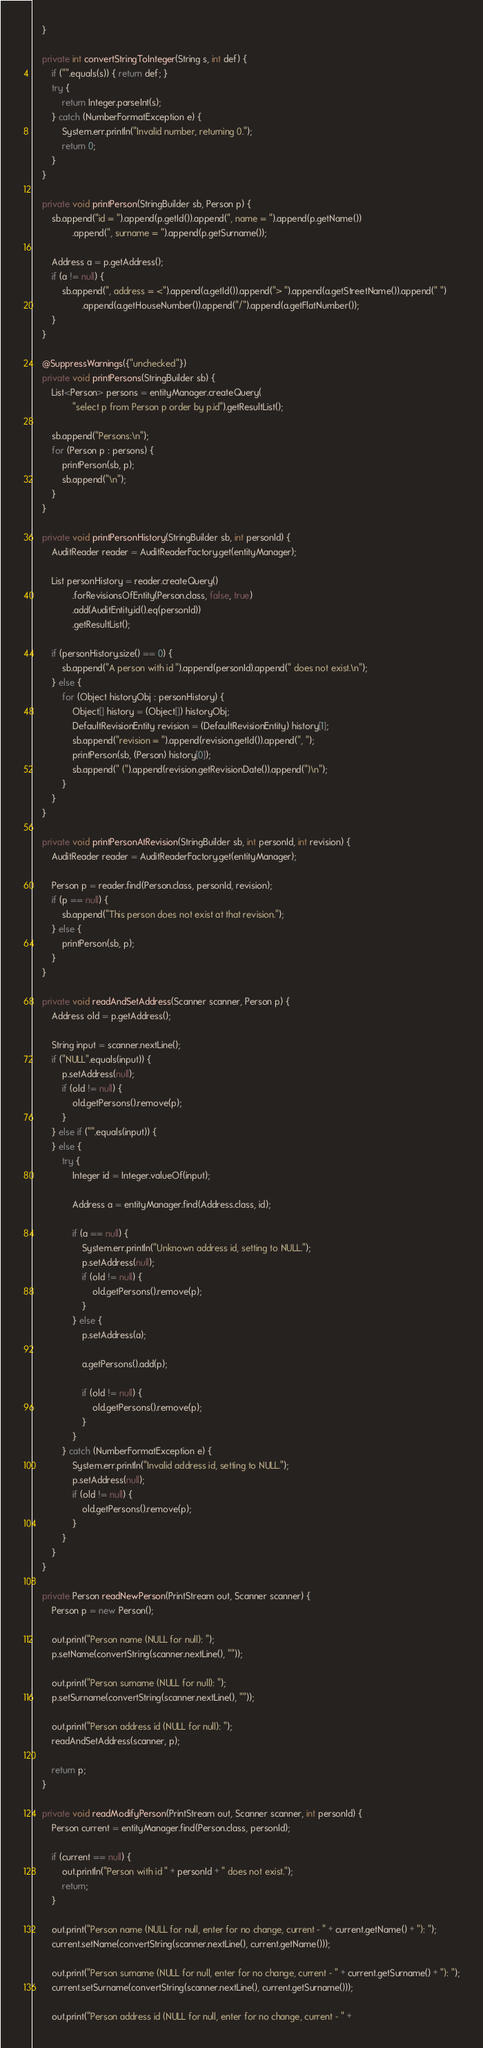<code> <loc_0><loc_0><loc_500><loc_500><_Java_>    }

    private int convertStringToInteger(String s, int def) {
        if ("".equals(s)) { return def; }
        try {
            return Integer.parseInt(s);
        } catch (NumberFormatException e) {
            System.err.println("Invalid number, returning 0.");
            return 0;
        }
    }

    private void printPerson(StringBuilder sb, Person p) {
        sb.append("id = ").append(p.getId()).append(", name = ").append(p.getName())
                .append(", surname = ").append(p.getSurname());

        Address a = p.getAddress();
        if (a != null) {
            sb.append(", address = <").append(a.getId()).append("> ").append(a.getStreetName()).append(" ")
                    .append(a.getHouseNumber()).append("/").append(a.getFlatNumber());
        }
    }

    @SuppressWarnings({"unchecked"})
    private void printPersons(StringBuilder sb) {
        List<Person> persons = entityManager.createQuery(
                "select p from Person p order by p.id").getResultList();

        sb.append("Persons:\n");
        for (Person p : persons) {
            printPerson(sb, p);
            sb.append("\n");
        }
    }

    private void printPersonHistory(StringBuilder sb, int personId) {
        AuditReader reader = AuditReaderFactory.get(entityManager);

        List personHistory = reader.createQuery()
                .forRevisionsOfEntity(Person.class, false, true)
                .add(AuditEntity.id().eq(personId))
                .getResultList();

        if (personHistory.size() == 0) {
            sb.append("A person with id ").append(personId).append(" does not exist.\n");
        } else {
            for (Object historyObj : personHistory) {
                Object[] history = (Object[]) historyObj;
                DefaultRevisionEntity revision = (DefaultRevisionEntity) history[1];
                sb.append("revision = ").append(revision.getId()).append(", ");
                printPerson(sb, (Person) history[0]);
                sb.append(" (").append(revision.getRevisionDate()).append(")\n");
            }
        }
    }

    private void printPersonAtRevision(StringBuilder sb, int personId, int revision) {
        AuditReader reader = AuditReaderFactory.get(entityManager);

        Person p = reader.find(Person.class, personId, revision);
        if (p == null) {
            sb.append("This person does not exist at that revision.");
        } else {
            printPerson(sb, p);
        }
    }

    private void readAndSetAddress(Scanner scanner, Person p) {
        Address old = p.getAddress();

        String input = scanner.nextLine();
        if ("NULL".equals(input)) {
            p.setAddress(null);
            if (old != null) {
                old.getPersons().remove(p);
            }
        } else if ("".equals(input)) {
        } else {
            try {
                Integer id = Integer.valueOf(input);

                Address a = entityManager.find(Address.class, id);

                if (a == null) {
                    System.err.println("Unknown address id, setting to NULL.");
                    p.setAddress(null);
                    if (old != null) {
                        old.getPersons().remove(p);
                    }
                } else {
                    p.setAddress(a);

                    a.getPersons().add(p);

                    if (old != null) {
                        old.getPersons().remove(p);
                    }
                }
            } catch (NumberFormatException e) {
                System.err.println("Invalid address id, setting to NULL.");
                p.setAddress(null);
                if (old != null) {
                    old.getPersons().remove(p);
                }
            }
        }
    }

    private Person readNewPerson(PrintStream out, Scanner scanner) {
        Person p = new Person();

        out.print("Person name (NULL for null): ");
        p.setName(convertString(scanner.nextLine(), ""));

        out.print("Person surname (NULL for null): ");
        p.setSurname(convertString(scanner.nextLine(), ""));

        out.print("Person address id (NULL for null): ");
        readAndSetAddress(scanner, p);

        return p;
    }

    private void readModifyPerson(PrintStream out, Scanner scanner, int personId) {
        Person current = entityManager.find(Person.class, personId);

        if (current == null) {
            out.println("Person with id " + personId + " does not exist.");
            return;
        }

        out.print("Person name (NULL for null, enter for no change, current - " + current.getName() + "): ");
        current.setName(convertString(scanner.nextLine(), current.getName()));

        out.print("Person surname (NULL for null, enter for no change, current - " + current.getSurname() + "): ");
        current.setSurname(convertString(scanner.nextLine(), current.getSurname()));

        out.print("Person address id (NULL for null, enter for no change, current - " +</code> 